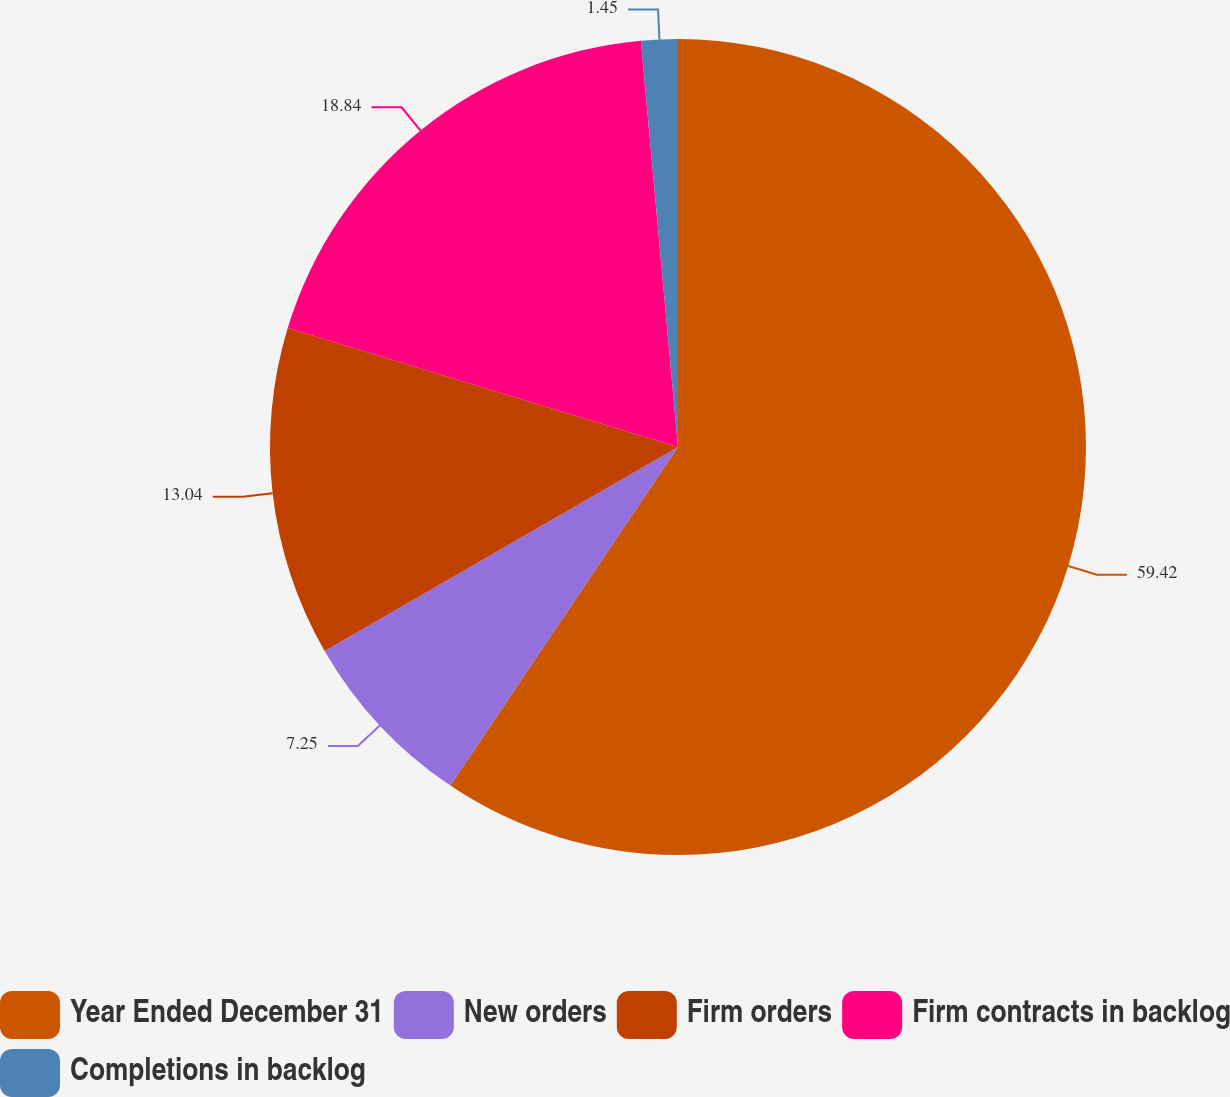<chart> <loc_0><loc_0><loc_500><loc_500><pie_chart><fcel>Year Ended December 31<fcel>New orders<fcel>Firm orders<fcel>Firm contracts in backlog<fcel>Completions in backlog<nl><fcel>59.42%<fcel>7.25%<fcel>13.04%<fcel>18.84%<fcel>1.45%<nl></chart> 